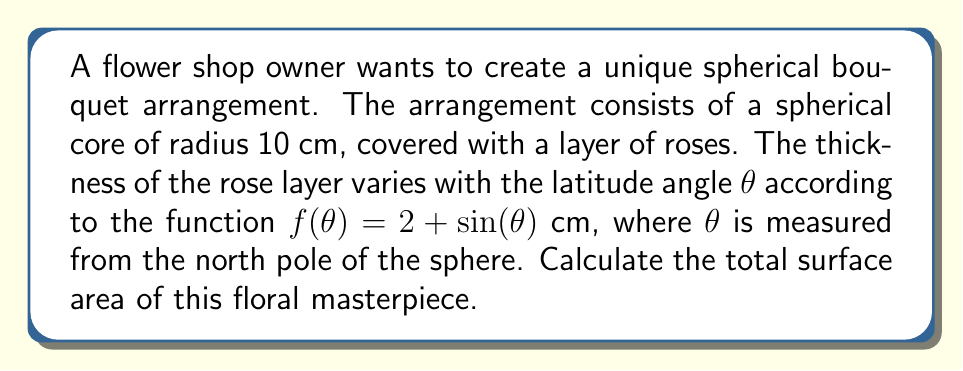Can you solve this math problem? Let's approach this step-by-step:

1) The surface area of a sphere with varying radius can be calculated using the formula:

   $$A = 2\pi \int_0^\pi [r(\theta)]^2 \sin(\theta) d\theta$$

   where $r(\theta)$ is the radius as a function of θ.

2) In this case, $r(\theta) = 10 + f(\theta) = 10 + 2 + \sin(\theta) = 12 + \sin(\theta)$

3) Substituting this into our formula:

   $$A = 2\pi \int_0^\pi [12 + \sin(\theta)]^2 \sin(\theta) d\theta$$

4) Expand the squared term:

   $$A = 2\pi \int_0^\pi [144 + 24\sin(\theta) + \sin^2(\theta)] \sin(\theta) d\theta$$

5) Distribute $\sin(\theta)$:

   $$A = 2\pi \int_0^\pi [144\sin(\theta) + 24\sin^2(\theta) + \sin^3(\theta)] d\theta$$

6) Integrate each term:
   
   - $\int_0^\pi 144\sin(\theta) d\theta = -144\cos(\theta)|_0^\pi = 288$
   - $\int_0^\pi 24\sin^2(\theta) d\theta = 24[\frac{\theta}{2} - \frac{\sin(2\theta)}{4}]_0^\pi = 12\pi$
   - $\int_0^\pi \sin^3(\theta) d\theta = [\frac{-\cos(\theta)}{3} + \frac{\cos^3(\theta)}{3}]_0^\pi = \frac{4}{3}$

7) Sum up the results:

   $$A = 2\pi (288 + 12\pi + \frac{4}{3})$$

8) Simplify:

   $$A = 576\pi + 24\pi^2 + \frac{8\pi}{3} \approx 2419.47 \text{ cm}^2$$
Answer: $576\pi + 24\pi^2 + \frac{8\pi}{3} \text{ cm}^2$ 